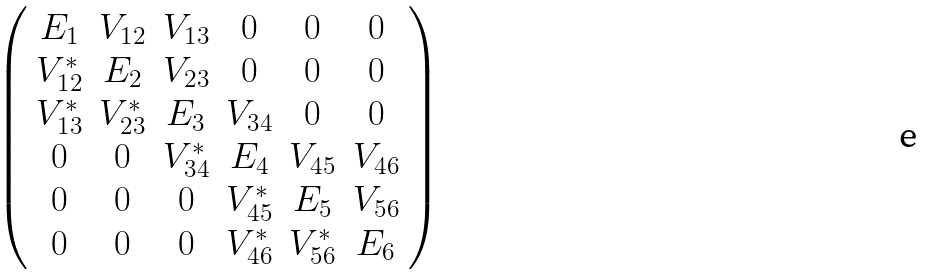Convert formula to latex. <formula><loc_0><loc_0><loc_500><loc_500>\begin{array} { c c c c c c c c } \left ( \begin{array} { c c c c c c } E _ { 1 } & V _ { 1 2 } & V _ { 1 3 } & 0 & 0 & 0 \\ V _ { 1 2 } ^ { * } & E _ { 2 } & V _ { 2 3 } & 0 & 0 & 0 \\ V _ { 1 3 } ^ { * } & V _ { 2 3 } ^ { * } & E _ { 3 } & V _ { 3 4 } & 0 & 0 \\ 0 & 0 & V _ { 3 4 } ^ { * } & E _ { 4 } & V _ { 4 5 } & V _ { 4 6 } \\ 0 & 0 & 0 & V _ { 4 5 } ^ { * } & E _ { 5 } & V _ { 5 6 } \\ 0 & 0 & 0 & V _ { 4 6 } ^ { * } & V _ { 5 6 } ^ { * } & E _ { 6 } \\ \end{array} \right ) \end{array}</formula> 